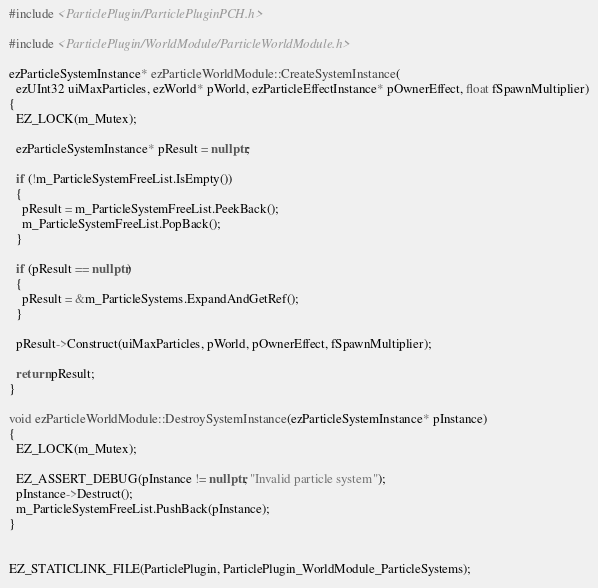<code> <loc_0><loc_0><loc_500><loc_500><_C++_>#include <ParticlePlugin/ParticlePluginPCH.h>

#include <ParticlePlugin/WorldModule/ParticleWorldModule.h>

ezParticleSystemInstance* ezParticleWorldModule::CreateSystemInstance(
  ezUInt32 uiMaxParticles, ezWorld* pWorld, ezParticleEffectInstance* pOwnerEffect, float fSpawnMultiplier)
{
  EZ_LOCK(m_Mutex);

  ezParticleSystemInstance* pResult = nullptr;

  if (!m_ParticleSystemFreeList.IsEmpty())
  {
    pResult = m_ParticleSystemFreeList.PeekBack();
    m_ParticleSystemFreeList.PopBack();
  }

  if (pResult == nullptr)
  {
    pResult = &m_ParticleSystems.ExpandAndGetRef();
  }

  pResult->Construct(uiMaxParticles, pWorld, pOwnerEffect, fSpawnMultiplier);

  return pResult;
}

void ezParticleWorldModule::DestroySystemInstance(ezParticleSystemInstance* pInstance)
{
  EZ_LOCK(m_Mutex);

  EZ_ASSERT_DEBUG(pInstance != nullptr, "Invalid particle system");
  pInstance->Destruct();
  m_ParticleSystemFreeList.PushBack(pInstance);
}


EZ_STATICLINK_FILE(ParticlePlugin, ParticlePlugin_WorldModule_ParticleSystems);
</code> 